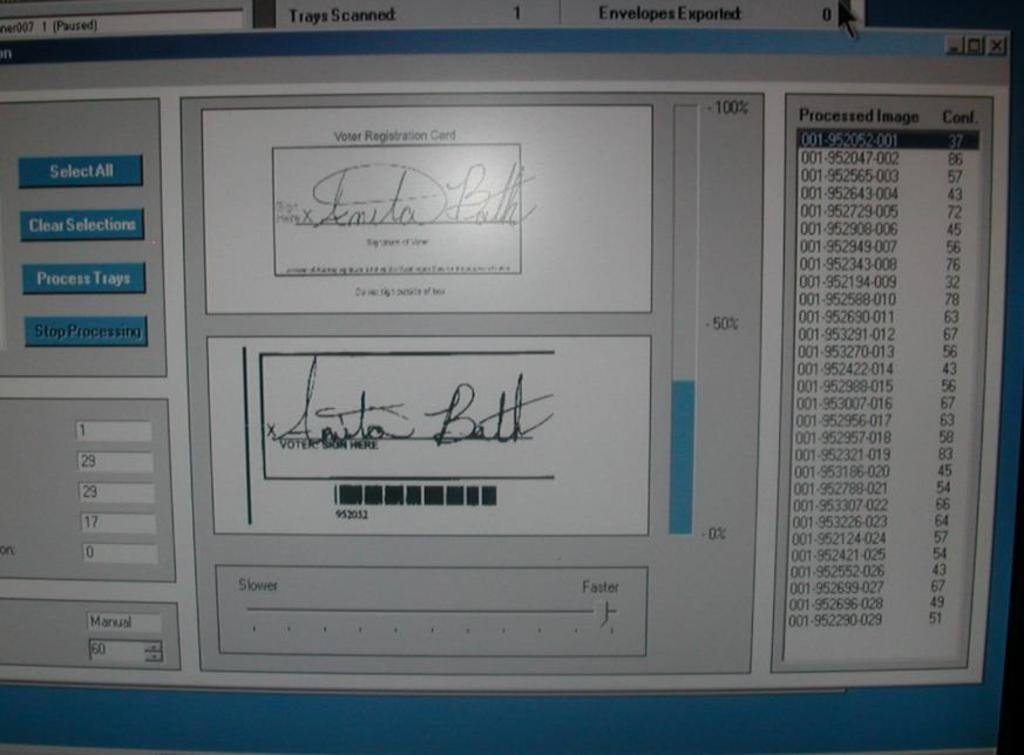<image>
Summarize the visual content of the image. A vote counting program showing a digital scan of a signature as it scans voter registration cards.. 